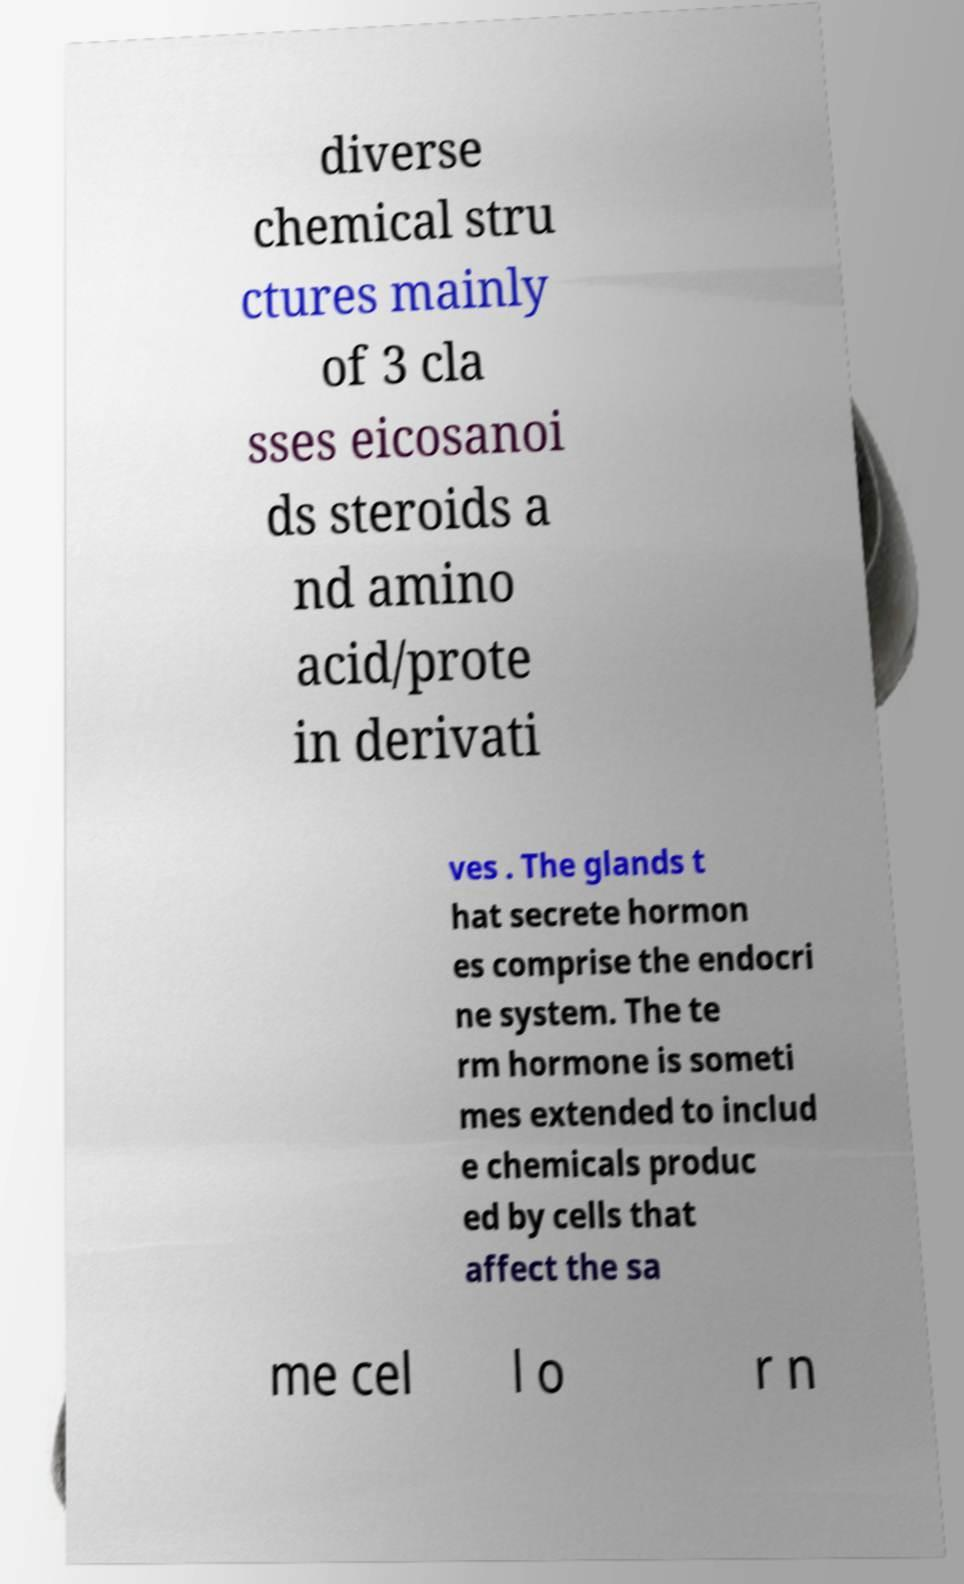Could you extract and type out the text from this image? diverse chemical stru ctures mainly of 3 cla sses eicosanoi ds steroids a nd amino acid/prote in derivati ves . The glands t hat secrete hormon es comprise the endocri ne system. The te rm hormone is someti mes extended to includ e chemicals produc ed by cells that affect the sa me cel l o r n 